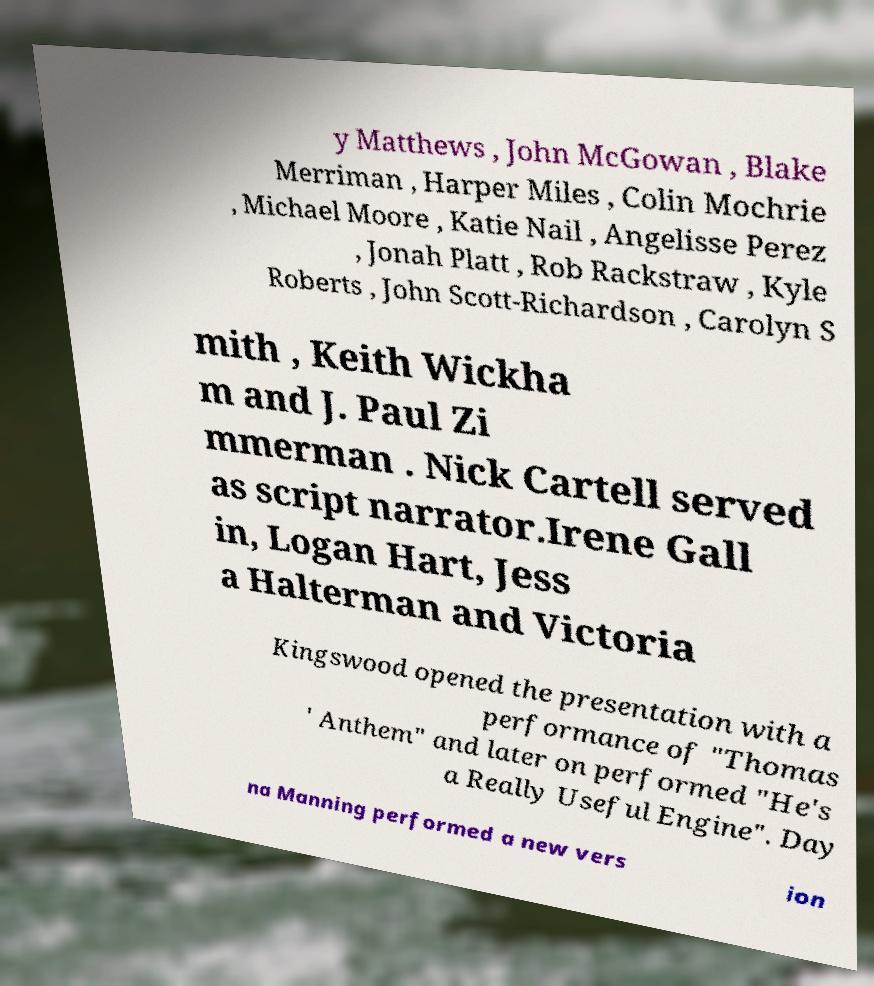Please identify and transcribe the text found in this image. y Matthews , John McGowan , Blake Merriman , Harper Miles , Colin Mochrie , Michael Moore , Katie Nail , Angelisse Perez , Jonah Platt , Rob Rackstraw , Kyle Roberts , John Scott-Richardson , Carolyn S mith , Keith Wickha m and J. Paul Zi mmerman . Nick Cartell served as script narrator.Irene Gall in, Logan Hart, Jess a Halterman and Victoria Kingswood opened the presentation with a performance of "Thomas ' Anthem" and later on performed "He's a Really Useful Engine". Day na Manning performed a new vers ion 